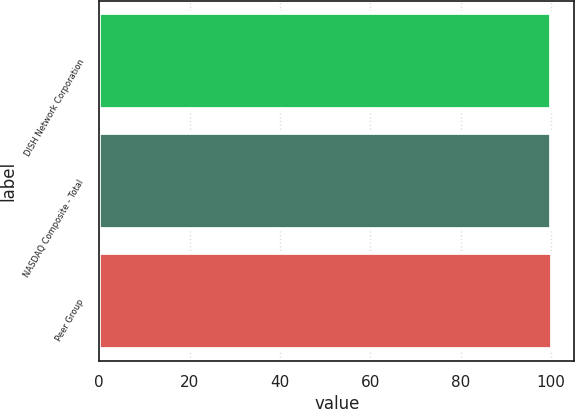Convert chart. <chart><loc_0><loc_0><loc_500><loc_500><bar_chart><fcel>DISH Network Corporation<fcel>NASDAQ Composite - Total<fcel>Peer Group<nl><fcel>100<fcel>100.1<fcel>100.2<nl></chart> 